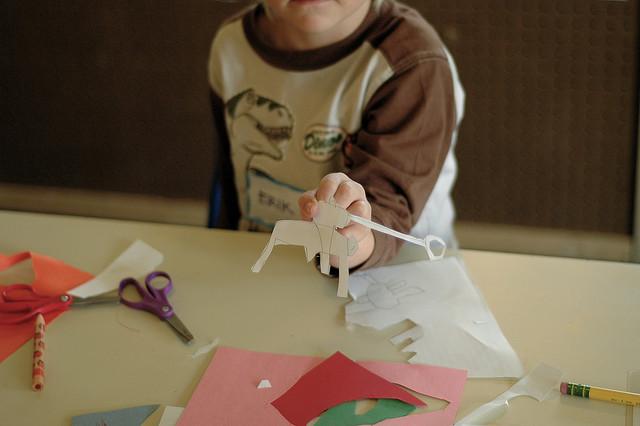What animal is on the kid shirt?
Write a very short answer. Dinosaur. What color is the scissors?
Keep it brief. Purple. How did the boy cut out the paper?
Be succinct. With scissors. What is the boy holding?
Concise answer only. Paper. 